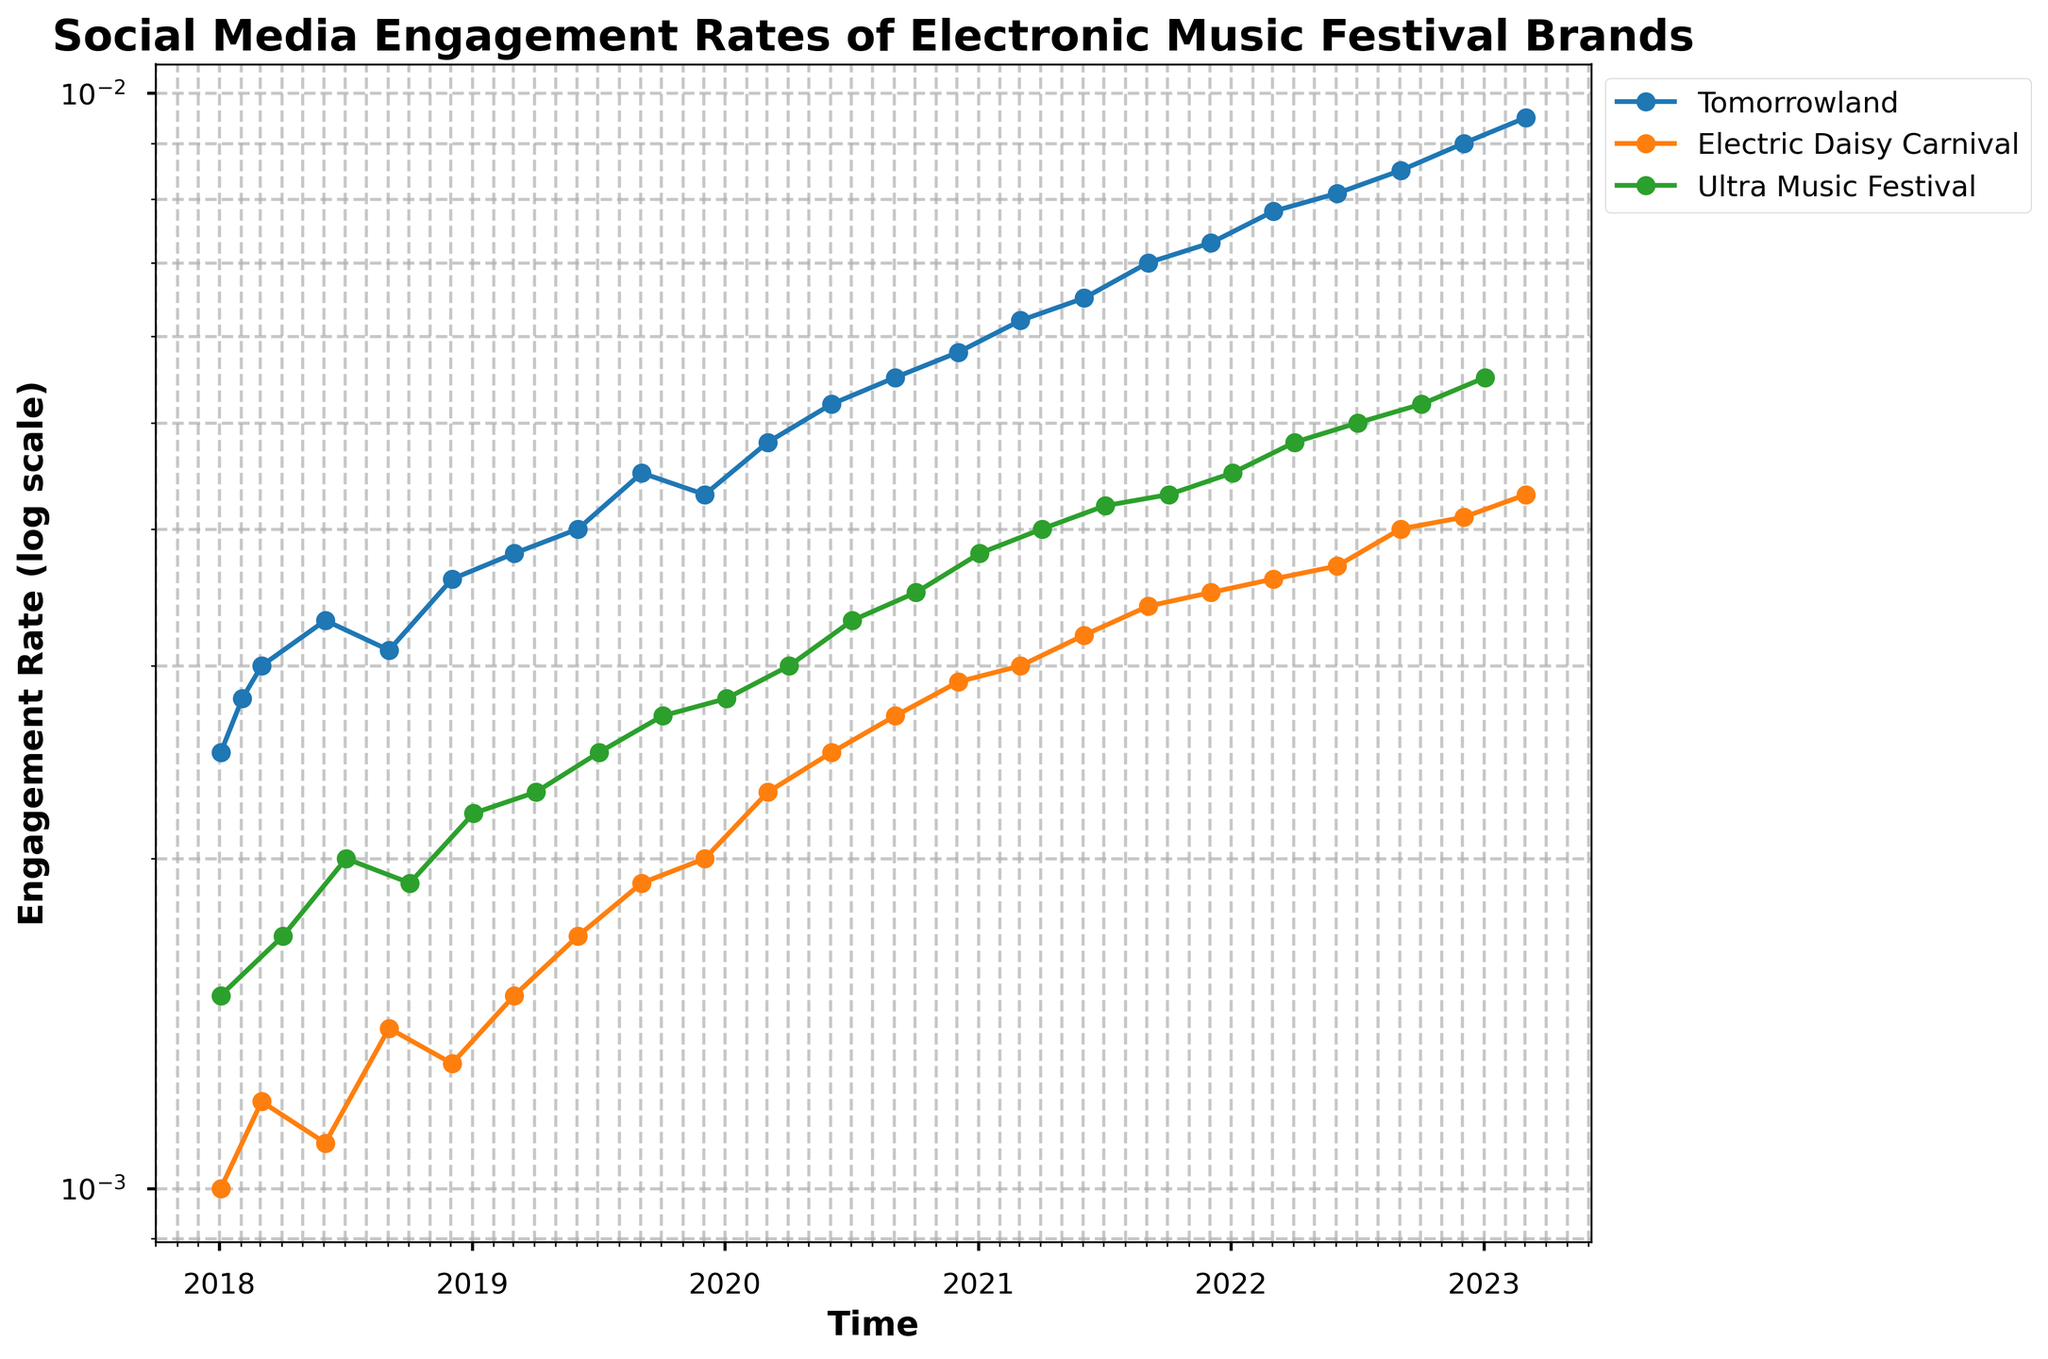What is the title of the plot? The title is written at the top center of the plot. It helps in understanding the subject of the visualization.
Answer: Social Media Engagement Rates of Electronic Music Festival Brands How is the engagement rate of Tomorrowland trending over time? By observing the line marked for Tomorrowland, it shows a clear upward trend in engagement rate from 2018 to 2023.
Answer: Upward How does the engagement rate of Electric Daisy Carnival in March 2020 compare to that in December 2022? Locate the points for Electric Daisy Carnival on the plot for March 2020 and December 2022, and then compare their vertical positions. The engagement rate in December 2022 is higher.
Answer: Higher in December 2022 Which festival had the highest engagement rate at any point in time, and when was that? By observing the peaks of the lines for the festivals, Tomorrowland has the highest engagement rate around March 2023.
Answer: Tomorrowland, March 2023 What is the trend in engagement rate for Ultra Music Festival from 2018 to 2023? Observe the line for Ultra Music Festival, noting the direction and slope over the years. The engagement rate shows a steady increase from 2018 to 2023.
Answer: Increasing Compare the engagement rate of Ultra Music Festival in January 2018 and January 2023. How did it change? Look at the points for Ultra Music Festival in January 2018 and January 2023 and note the vertical positions. The engagement rate increased.
Answer: Increased Which festival had the lowest engagement rate in January 2018? By comparing the starting points of the lines for January 2018, Electric Daisy Carnival has the lowest engagement rate.
Answer: Electric Daisy Carnival Between March 2020 and June 2020, which festival showed the highest increase in engagement rates? Compare the slopes of the lines between March 2020 and June 2020. Tomorrowland has the steepest slope, indicating the highest increase.
Answer: Tomorrowland How often does the data in the plot get updated for each festival? Observe the time interval between consecutive data points for each festival. The data appears to be updated every 3 months.
Answer: Every 3 months Which festival showed the most consistent increase in engagement rate from 2018 to 2023? Compare the smoothness and steadiness of the upward slopes for each festival. Ultra Music Festival shows the most consistent increase without sharp fluctuations.
Answer: Ultra Music Festival 